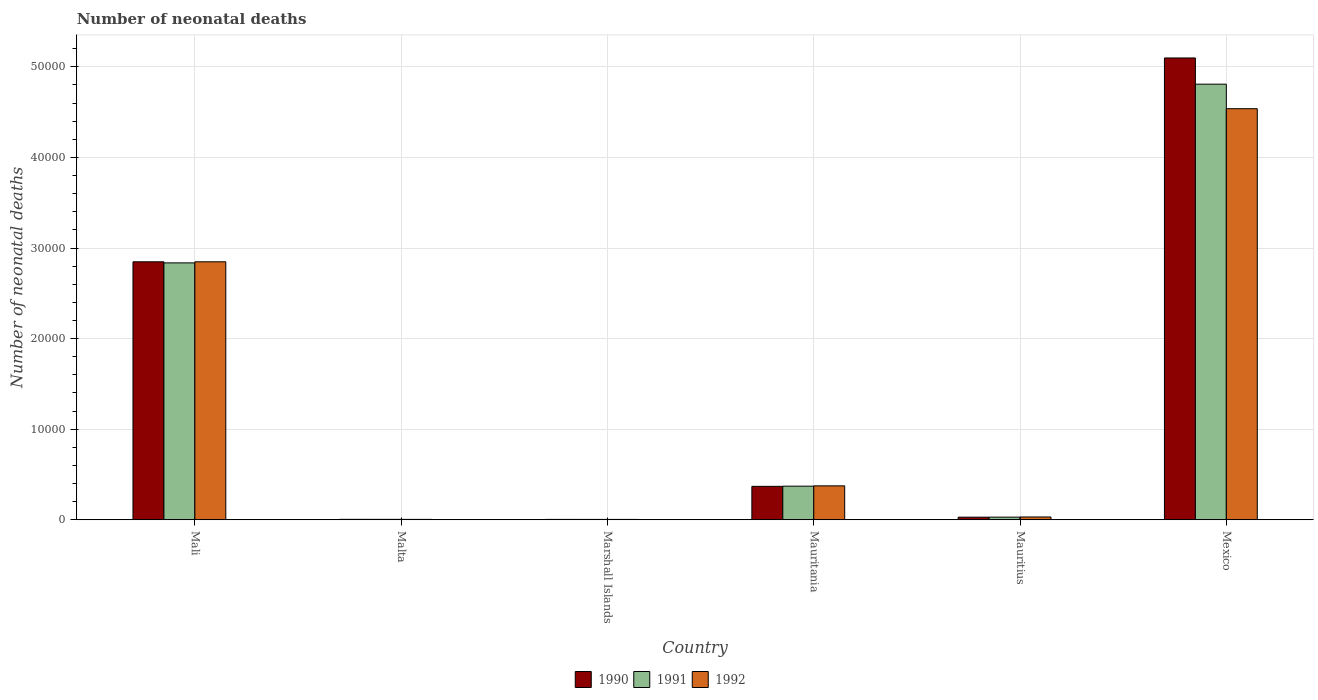How many different coloured bars are there?
Offer a terse response. 3. Are the number of bars on each tick of the X-axis equal?
Keep it short and to the point. Yes. How many bars are there on the 3rd tick from the right?
Offer a very short reply. 3. What is the label of the 1st group of bars from the left?
Make the answer very short. Mali. What is the number of neonatal deaths in in 1992 in Mauritania?
Give a very brief answer. 3743. Across all countries, what is the maximum number of neonatal deaths in in 1991?
Your response must be concise. 4.81e+04. Across all countries, what is the minimum number of neonatal deaths in in 1992?
Your response must be concise. 38. In which country was the number of neonatal deaths in in 1991 minimum?
Your response must be concise. Marshall Islands. What is the total number of neonatal deaths in in 1991 in the graph?
Keep it short and to the point. 8.05e+04. What is the difference between the number of neonatal deaths in in 1991 in Mali and that in Mexico?
Your answer should be very brief. -1.97e+04. What is the difference between the number of neonatal deaths in in 1992 in Mauritania and the number of neonatal deaths in in 1990 in Mexico?
Offer a very short reply. -4.72e+04. What is the average number of neonatal deaths in in 1992 per country?
Your answer should be very brief. 1.30e+04. What is the difference between the number of neonatal deaths in of/in 1992 and number of neonatal deaths in of/in 1991 in Malta?
Provide a short and direct response. -3. What is the ratio of the number of neonatal deaths in in 1991 in Mali to that in Mauritania?
Your answer should be very brief. 7.65. Is the number of neonatal deaths in in 1990 in Mali less than that in Mexico?
Your answer should be compact. Yes. Is the difference between the number of neonatal deaths in in 1992 in Mali and Marshall Islands greater than the difference between the number of neonatal deaths in in 1991 in Mali and Marshall Islands?
Keep it short and to the point. Yes. What is the difference between the highest and the second highest number of neonatal deaths in in 1991?
Make the answer very short. 4.44e+04. What is the difference between the highest and the lowest number of neonatal deaths in in 1992?
Offer a very short reply. 4.53e+04. In how many countries, is the number of neonatal deaths in in 1990 greater than the average number of neonatal deaths in in 1990 taken over all countries?
Keep it short and to the point. 2. What does the 2nd bar from the right in Mauritania represents?
Make the answer very short. 1991. Is it the case that in every country, the sum of the number of neonatal deaths in in 1990 and number of neonatal deaths in in 1992 is greater than the number of neonatal deaths in in 1991?
Your response must be concise. Yes. Are all the bars in the graph horizontal?
Keep it short and to the point. No. Are the values on the major ticks of Y-axis written in scientific E-notation?
Ensure brevity in your answer.  No. Where does the legend appear in the graph?
Make the answer very short. Bottom center. How are the legend labels stacked?
Your response must be concise. Horizontal. What is the title of the graph?
Offer a very short reply. Number of neonatal deaths. Does "1964" appear as one of the legend labels in the graph?
Offer a terse response. No. What is the label or title of the Y-axis?
Provide a succinct answer. Number of neonatal deaths. What is the Number of neonatal deaths in 1990 in Mali?
Keep it short and to the point. 2.85e+04. What is the Number of neonatal deaths in 1991 in Mali?
Your response must be concise. 2.84e+04. What is the Number of neonatal deaths in 1992 in Mali?
Make the answer very short. 2.85e+04. What is the Number of neonatal deaths of 1991 in Marshall Islands?
Keep it short and to the point. 39. What is the Number of neonatal deaths of 1992 in Marshall Islands?
Your answer should be compact. 38. What is the Number of neonatal deaths of 1990 in Mauritania?
Provide a succinct answer. 3690. What is the Number of neonatal deaths in 1991 in Mauritania?
Your response must be concise. 3709. What is the Number of neonatal deaths in 1992 in Mauritania?
Give a very brief answer. 3743. What is the Number of neonatal deaths of 1990 in Mauritius?
Give a very brief answer. 285. What is the Number of neonatal deaths of 1991 in Mauritius?
Offer a very short reply. 289. What is the Number of neonatal deaths in 1992 in Mauritius?
Your response must be concise. 307. What is the Number of neonatal deaths of 1990 in Mexico?
Provide a short and direct response. 5.10e+04. What is the Number of neonatal deaths in 1991 in Mexico?
Provide a short and direct response. 4.81e+04. What is the Number of neonatal deaths in 1992 in Mexico?
Give a very brief answer. 4.54e+04. Across all countries, what is the maximum Number of neonatal deaths in 1990?
Your answer should be very brief. 5.10e+04. Across all countries, what is the maximum Number of neonatal deaths in 1991?
Provide a short and direct response. 4.81e+04. Across all countries, what is the maximum Number of neonatal deaths in 1992?
Offer a very short reply. 4.54e+04. Across all countries, what is the minimum Number of neonatal deaths of 1991?
Your answer should be compact. 39. What is the total Number of neonatal deaths of 1990 in the graph?
Ensure brevity in your answer.  8.35e+04. What is the total Number of neonatal deaths of 1991 in the graph?
Your answer should be compact. 8.05e+04. What is the total Number of neonatal deaths of 1992 in the graph?
Make the answer very short. 7.80e+04. What is the difference between the Number of neonatal deaths of 1990 in Mali and that in Malta?
Your answer should be compact. 2.84e+04. What is the difference between the Number of neonatal deaths of 1991 in Mali and that in Malta?
Keep it short and to the point. 2.83e+04. What is the difference between the Number of neonatal deaths of 1992 in Mali and that in Malta?
Your answer should be very brief. 2.84e+04. What is the difference between the Number of neonatal deaths in 1990 in Mali and that in Marshall Islands?
Offer a very short reply. 2.84e+04. What is the difference between the Number of neonatal deaths of 1991 in Mali and that in Marshall Islands?
Your answer should be very brief. 2.83e+04. What is the difference between the Number of neonatal deaths of 1992 in Mali and that in Marshall Islands?
Your answer should be very brief. 2.84e+04. What is the difference between the Number of neonatal deaths of 1990 in Mali and that in Mauritania?
Ensure brevity in your answer.  2.48e+04. What is the difference between the Number of neonatal deaths in 1991 in Mali and that in Mauritania?
Your answer should be compact. 2.46e+04. What is the difference between the Number of neonatal deaths in 1992 in Mali and that in Mauritania?
Ensure brevity in your answer.  2.47e+04. What is the difference between the Number of neonatal deaths in 1990 in Mali and that in Mauritius?
Offer a very short reply. 2.82e+04. What is the difference between the Number of neonatal deaths in 1991 in Mali and that in Mauritius?
Offer a terse response. 2.81e+04. What is the difference between the Number of neonatal deaths in 1992 in Mali and that in Mauritius?
Provide a succinct answer. 2.82e+04. What is the difference between the Number of neonatal deaths of 1990 in Mali and that in Mexico?
Keep it short and to the point. -2.25e+04. What is the difference between the Number of neonatal deaths of 1991 in Mali and that in Mexico?
Offer a terse response. -1.97e+04. What is the difference between the Number of neonatal deaths of 1992 in Mali and that in Mexico?
Provide a short and direct response. -1.69e+04. What is the difference between the Number of neonatal deaths of 1990 in Malta and that in Mauritania?
Your response must be concise. -3643. What is the difference between the Number of neonatal deaths in 1991 in Malta and that in Mauritania?
Keep it short and to the point. -3664. What is the difference between the Number of neonatal deaths of 1992 in Malta and that in Mauritania?
Keep it short and to the point. -3701. What is the difference between the Number of neonatal deaths of 1990 in Malta and that in Mauritius?
Your answer should be compact. -238. What is the difference between the Number of neonatal deaths in 1991 in Malta and that in Mauritius?
Keep it short and to the point. -244. What is the difference between the Number of neonatal deaths in 1992 in Malta and that in Mauritius?
Your answer should be very brief. -265. What is the difference between the Number of neonatal deaths in 1990 in Malta and that in Mexico?
Your answer should be compact. -5.09e+04. What is the difference between the Number of neonatal deaths in 1991 in Malta and that in Mexico?
Provide a short and direct response. -4.80e+04. What is the difference between the Number of neonatal deaths of 1992 in Malta and that in Mexico?
Offer a very short reply. -4.53e+04. What is the difference between the Number of neonatal deaths in 1990 in Marshall Islands and that in Mauritania?
Make the answer very short. -3650. What is the difference between the Number of neonatal deaths in 1991 in Marshall Islands and that in Mauritania?
Provide a short and direct response. -3670. What is the difference between the Number of neonatal deaths in 1992 in Marshall Islands and that in Mauritania?
Your answer should be very brief. -3705. What is the difference between the Number of neonatal deaths in 1990 in Marshall Islands and that in Mauritius?
Offer a very short reply. -245. What is the difference between the Number of neonatal deaths of 1991 in Marshall Islands and that in Mauritius?
Offer a very short reply. -250. What is the difference between the Number of neonatal deaths of 1992 in Marshall Islands and that in Mauritius?
Your answer should be compact. -269. What is the difference between the Number of neonatal deaths in 1990 in Marshall Islands and that in Mexico?
Your answer should be very brief. -5.09e+04. What is the difference between the Number of neonatal deaths of 1991 in Marshall Islands and that in Mexico?
Offer a very short reply. -4.80e+04. What is the difference between the Number of neonatal deaths in 1992 in Marshall Islands and that in Mexico?
Your answer should be compact. -4.53e+04. What is the difference between the Number of neonatal deaths of 1990 in Mauritania and that in Mauritius?
Provide a succinct answer. 3405. What is the difference between the Number of neonatal deaths of 1991 in Mauritania and that in Mauritius?
Your answer should be very brief. 3420. What is the difference between the Number of neonatal deaths in 1992 in Mauritania and that in Mauritius?
Ensure brevity in your answer.  3436. What is the difference between the Number of neonatal deaths in 1990 in Mauritania and that in Mexico?
Provide a succinct answer. -4.73e+04. What is the difference between the Number of neonatal deaths of 1991 in Mauritania and that in Mexico?
Offer a very short reply. -4.44e+04. What is the difference between the Number of neonatal deaths of 1992 in Mauritania and that in Mexico?
Give a very brief answer. -4.16e+04. What is the difference between the Number of neonatal deaths in 1990 in Mauritius and that in Mexico?
Your response must be concise. -5.07e+04. What is the difference between the Number of neonatal deaths of 1991 in Mauritius and that in Mexico?
Offer a terse response. -4.78e+04. What is the difference between the Number of neonatal deaths of 1992 in Mauritius and that in Mexico?
Give a very brief answer. -4.51e+04. What is the difference between the Number of neonatal deaths in 1990 in Mali and the Number of neonatal deaths in 1991 in Malta?
Give a very brief answer. 2.84e+04. What is the difference between the Number of neonatal deaths of 1990 in Mali and the Number of neonatal deaths of 1992 in Malta?
Give a very brief answer. 2.84e+04. What is the difference between the Number of neonatal deaths in 1991 in Mali and the Number of neonatal deaths in 1992 in Malta?
Your answer should be compact. 2.83e+04. What is the difference between the Number of neonatal deaths in 1990 in Mali and the Number of neonatal deaths in 1991 in Marshall Islands?
Make the answer very short. 2.84e+04. What is the difference between the Number of neonatal deaths of 1990 in Mali and the Number of neonatal deaths of 1992 in Marshall Islands?
Make the answer very short. 2.84e+04. What is the difference between the Number of neonatal deaths of 1991 in Mali and the Number of neonatal deaths of 1992 in Marshall Islands?
Ensure brevity in your answer.  2.83e+04. What is the difference between the Number of neonatal deaths in 1990 in Mali and the Number of neonatal deaths in 1991 in Mauritania?
Provide a succinct answer. 2.48e+04. What is the difference between the Number of neonatal deaths of 1990 in Mali and the Number of neonatal deaths of 1992 in Mauritania?
Your answer should be very brief. 2.47e+04. What is the difference between the Number of neonatal deaths of 1991 in Mali and the Number of neonatal deaths of 1992 in Mauritania?
Keep it short and to the point. 2.46e+04. What is the difference between the Number of neonatal deaths of 1990 in Mali and the Number of neonatal deaths of 1991 in Mauritius?
Provide a short and direct response. 2.82e+04. What is the difference between the Number of neonatal deaths in 1990 in Mali and the Number of neonatal deaths in 1992 in Mauritius?
Keep it short and to the point. 2.82e+04. What is the difference between the Number of neonatal deaths of 1991 in Mali and the Number of neonatal deaths of 1992 in Mauritius?
Your answer should be very brief. 2.81e+04. What is the difference between the Number of neonatal deaths in 1990 in Mali and the Number of neonatal deaths in 1991 in Mexico?
Give a very brief answer. -1.96e+04. What is the difference between the Number of neonatal deaths of 1990 in Mali and the Number of neonatal deaths of 1992 in Mexico?
Your response must be concise. -1.69e+04. What is the difference between the Number of neonatal deaths in 1991 in Mali and the Number of neonatal deaths in 1992 in Mexico?
Ensure brevity in your answer.  -1.70e+04. What is the difference between the Number of neonatal deaths of 1990 in Malta and the Number of neonatal deaths of 1992 in Marshall Islands?
Offer a very short reply. 9. What is the difference between the Number of neonatal deaths in 1991 in Malta and the Number of neonatal deaths in 1992 in Marshall Islands?
Provide a short and direct response. 7. What is the difference between the Number of neonatal deaths in 1990 in Malta and the Number of neonatal deaths in 1991 in Mauritania?
Your answer should be very brief. -3662. What is the difference between the Number of neonatal deaths in 1990 in Malta and the Number of neonatal deaths in 1992 in Mauritania?
Provide a succinct answer. -3696. What is the difference between the Number of neonatal deaths of 1991 in Malta and the Number of neonatal deaths of 1992 in Mauritania?
Your answer should be compact. -3698. What is the difference between the Number of neonatal deaths in 1990 in Malta and the Number of neonatal deaths in 1991 in Mauritius?
Keep it short and to the point. -242. What is the difference between the Number of neonatal deaths of 1990 in Malta and the Number of neonatal deaths of 1992 in Mauritius?
Provide a short and direct response. -260. What is the difference between the Number of neonatal deaths of 1991 in Malta and the Number of neonatal deaths of 1992 in Mauritius?
Keep it short and to the point. -262. What is the difference between the Number of neonatal deaths of 1990 in Malta and the Number of neonatal deaths of 1991 in Mexico?
Your answer should be compact. -4.80e+04. What is the difference between the Number of neonatal deaths in 1990 in Malta and the Number of neonatal deaths in 1992 in Mexico?
Your answer should be compact. -4.53e+04. What is the difference between the Number of neonatal deaths in 1991 in Malta and the Number of neonatal deaths in 1992 in Mexico?
Provide a succinct answer. -4.53e+04. What is the difference between the Number of neonatal deaths in 1990 in Marshall Islands and the Number of neonatal deaths in 1991 in Mauritania?
Keep it short and to the point. -3669. What is the difference between the Number of neonatal deaths of 1990 in Marshall Islands and the Number of neonatal deaths of 1992 in Mauritania?
Ensure brevity in your answer.  -3703. What is the difference between the Number of neonatal deaths in 1991 in Marshall Islands and the Number of neonatal deaths in 1992 in Mauritania?
Make the answer very short. -3704. What is the difference between the Number of neonatal deaths of 1990 in Marshall Islands and the Number of neonatal deaths of 1991 in Mauritius?
Your response must be concise. -249. What is the difference between the Number of neonatal deaths of 1990 in Marshall Islands and the Number of neonatal deaths of 1992 in Mauritius?
Provide a succinct answer. -267. What is the difference between the Number of neonatal deaths in 1991 in Marshall Islands and the Number of neonatal deaths in 1992 in Mauritius?
Provide a succinct answer. -268. What is the difference between the Number of neonatal deaths in 1990 in Marshall Islands and the Number of neonatal deaths in 1991 in Mexico?
Offer a terse response. -4.80e+04. What is the difference between the Number of neonatal deaths in 1990 in Marshall Islands and the Number of neonatal deaths in 1992 in Mexico?
Ensure brevity in your answer.  -4.53e+04. What is the difference between the Number of neonatal deaths of 1991 in Marshall Islands and the Number of neonatal deaths of 1992 in Mexico?
Make the answer very short. -4.53e+04. What is the difference between the Number of neonatal deaths in 1990 in Mauritania and the Number of neonatal deaths in 1991 in Mauritius?
Provide a succinct answer. 3401. What is the difference between the Number of neonatal deaths in 1990 in Mauritania and the Number of neonatal deaths in 1992 in Mauritius?
Ensure brevity in your answer.  3383. What is the difference between the Number of neonatal deaths in 1991 in Mauritania and the Number of neonatal deaths in 1992 in Mauritius?
Keep it short and to the point. 3402. What is the difference between the Number of neonatal deaths in 1990 in Mauritania and the Number of neonatal deaths in 1991 in Mexico?
Your answer should be compact. -4.44e+04. What is the difference between the Number of neonatal deaths in 1990 in Mauritania and the Number of neonatal deaths in 1992 in Mexico?
Provide a succinct answer. -4.17e+04. What is the difference between the Number of neonatal deaths in 1991 in Mauritania and the Number of neonatal deaths in 1992 in Mexico?
Ensure brevity in your answer.  -4.17e+04. What is the difference between the Number of neonatal deaths of 1990 in Mauritius and the Number of neonatal deaths of 1991 in Mexico?
Provide a succinct answer. -4.78e+04. What is the difference between the Number of neonatal deaths in 1990 in Mauritius and the Number of neonatal deaths in 1992 in Mexico?
Your answer should be very brief. -4.51e+04. What is the difference between the Number of neonatal deaths in 1991 in Mauritius and the Number of neonatal deaths in 1992 in Mexico?
Your response must be concise. -4.51e+04. What is the average Number of neonatal deaths in 1990 per country?
Give a very brief answer. 1.39e+04. What is the average Number of neonatal deaths of 1991 per country?
Your response must be concise. 1.34e+04. What is the average Number of neonatal deaths in 1992 per country?
Your answer should be very brief. 1.30e+04. What is the difference between the Number of neonatal deaths of 1990 and Number of neonatal deaths of 1991 in Mali?
Your answer should be compact. 120. What is the difference between the Number of neonatal deaths in 1990 and Number of neonatal deaths in 1992 in Mali?
Offer a terse response. 0. What is the difference between the Number of neonatal deaths in 1991 and Number of neonatal deaths in 1992 in Mali?
Give a very brief answer. -120. What is the difference between the Number of neonatal deaths of 1990 and Number of neonatal deaths of 1991 in Malta?
Make the answer very short. 2. What is the difference between the Number of neonatal deaths of 1990 and Number of neonatal deaths of 1991 in Mauritania?
Keep it short and to the point. -19. What is the difference between the Number of neonatal deaths of 1990 and Number of neonatal deaths of 1992 in Mauritania?
Provide a succinct answer. -53. What is the difference between the Number of neonatal deaths in 1991 and Number of neonatal deaths in 1992 in Mauritania?
Ensure brevity in your answer.  -34. What is the difference between the Number of neonatal deaths of 1990 and Number of neonatal deaths of 1992 in Mauritius?
Provide a short and direct response. -22. What is the difference between the Number of neonatal deaths of 1990 and Number of neonatal deaths of 1991 in Mexico?
Your response must be concise. 2892. What is the difference between the Number of neonatal deaths of 1990 and Number of neonatal deaths of 1992 in Mexico?
Make the answer very short. 5601. What is the difference between the Number of neonatal deaths in 1991 and Number of neonatal deaths in 1992 in Mexico?
Offer a terse response. 2709. What is the ratio of the Number of neonatal deaths of 1990 in Mali to that in Malta?
Keep it short and to the point. 605.91. What is the ratio of the Number of neonatal deaths in 1991 in Mali to that in Malta?
Offer a terse response. 630.18. What is the ratio of the Number of neonatal deaths of 1992 in Mali to that in Malta?
Make the answer very short. 678.05. What is the ratio of the Number of neonatal deaths of 1990 in Mali to that in Marshall Islands?
Provide a succinct answer. 711.95. What is the ratio of the Number of neonatal deaths in 1991 in Mali to that in Marshall Islands?
Provide a succinct answer. 727.13. What is the ratio of the Number of neonatal deaths of 1992 in Mali to that in Marshall Islands?
Offer a terse response. 749.42. What is the ratio of the Number of neonatal deaths in 1990 in Mali to that in Mauritania?
Give a very brief answer. 7.72. What is the ratio of the Number of neonatal deaths in 1991 in Mali to that in Mauritania?
Provide a succinct answer. 7.65. What is the ratio of the Number of neonatal deaths in 1992 in Mali to that in Mauritania?
Keep it short and to the point. 7.61. What is the ratio of the Number of neonatal deaths of 1990 in Mali to that in Mauritius?
Give a very brief answer. 99.92. What is the ratio of the Number of neonatal deaths in 1991 in Mali to that in Mauritius?
Your answer should be compact. 98.12. What is the ratio of the Number of neonatal deaths in 1992 in Mali to that in Mauritius?
Provide a succinct answer. 92.76. What is the ratio of the Number of neonatal deaths in 1990 in Mali to that in Mexico?
Offer a very short reply. 0.56. What is the ratio of the Number of neonatal deaths of 1991 in Mali to that in Mexico?
Provide a short and direct response. 0.59. What is the ratio of the Number of neonatal deaths in 1992 in Mali to that in Mexico?
Ensure brevity in your answer.  0.63. What is the ratio of the Number of neonatal deaths of 1990 in Malta to that in Marshall Islands?
Offer a terse response. 1.18. What is the ratio of the Number of neonatal deaths in 1991 in Malta to that in Marshall Islands?
Give a very brief answer. 1.15. What is the ratio of the Number of neonatal deaths in 1992 in Malta to that in Marshall Islands?
Your answer should be very brief. 1.11. What is the ratio of the Number of neonatal deaths of 1990 in Malta to that in Mauritania?
Give a very brief answer. 0.01. What is the ratio of the Number of neonatal deaths in 1991 in Malta to that in Mauritania?
Provide a succinct answer. 0.01. What is the ratio of the Number of neonatal deaths in 1992 in Malta to that in Mauritania?
Your answer should be compact. 0.01. What is the ratio of the Number of neonatal deaths of 1990 in Malta to that in Mauritius?
Your answer should be compact. 0.16. What is the ratio of the Number of neonatal deaths of 1991 in Malta to that in Mauritius?
Ensure brevity in your answer.  0.16. What is the ratio of the Number of neonatal deaths of 1992 in Malta to that in Mauritius?
Provide a succinct answer. 0.14. What is the ratio of the Number of neonatal deaths in 1990 in Malta to that in Mexico?
Keep it short and to the point. 0. What is the ratio of the Number of neonatal deaths of 1991 in Malta to that in Mexico?
Provide a succinct answer. 0. What is the ratio of the Number of neonatal deaths of 1992 in Malta to that in Mexico?
Provide a succinct answer. 0. What is the ratio of the Number of neonatal deaths of 1990 in Marshall Islands to that in Mauritania?
Give a very brief answer. 0.01. What is the ratio of the Number of neonatal deaths of 1991 in Marshall Islands to that in Mauritania?
Ensure brevity in your answer.  0.01. What is the ratio of the Number of neonatal deaths in 1992 in Marshall Islands to that in Mauritania?
Your answer should be compact. 0.01. What is the ratio of the Number of neonatal deaths in 1990 in Marshall Islands to that in Mauritius?
Your answer should be very brief. 0.14. What is the ratio of the Number of neonatal deaths in 1991 in Marshall Islands to that in Mauritius?
Offer a very short reply. 0.13. What is the ratio of the Number of neonatal deaths in 1992 in Marshall Islands to that in Mauritius?
Your answer should be compact. 0.12. What is the ratio of the Number of neonatal deaths of 1990 in Marshall Islands to that in Mexico?
Ensure brevity in your answer.  0. What is the ratio of the Number of neonatal deaths in 1991 in Marshall Islands to that in Mexico?
Your answer should be very brief. 0. What is the ratio of the Number of neonatal deaths in 1992 in Marshall Islands to that in Mexico?
Your answer should be very brief. 0. What is the ratio of the Number of neonatal deaths in 1990 in Mauritania to that in Mauritius?
Offer a terse response. 12.95. What is the ratio of the Number of neonatal deaths of 1991 in Mauritania to that in Mauritius?
Give a very brief answer. 12.83. What is the ratio of the Number of neonatal deaths in 1992 in Mauritania to that in Mauritius?
Your response must be concise. 12.19. What is the ratio of the Number of neonatal deaths of 1990 in Mauritania to that in Mexico?
Provide a succinct answer. 0.07. What is the ratio of the Number of neonatal deaths of 1991 in Mauritania to that in Mexico?
Give a very brief answer. 0.08. What is the ratio of the Number of neonatal deaths of 1992 in Mauritania to that in Mexico?
Your answer should be compact. 0.08. What is the ratio of the Number of neonatal deaths of 1990 in Mauritius to that in Mexico?
Your response must be concise. 0.01. What is the ratio of the Number of neonatal deaths of 1991 in Mauritius to that in Mexico?
Your response must be concise. 0.01. What is the ratio of the Number of neonatal deaths of 1992 in Mauritius to that in Mexico?
Provide a short and direct response. 0.01. What is the difference between the highest and the second highest Number of neonatal deaths of 1990?
Keep it short and to the point. 2.25e+04. What is the difference between the highest and the second highest Number of neonatal deaths in 1991?
Provide a succinct answer. 1.97e+04. What is the difference between the highest and the second highest Number of neonatal deaths in 1992?
Keep it short and to the point. 1.69e+04. What is the difference between the highest and the lowest Number of neonatal deaths of 1990?
Provide a succinct answer. 5.09e+04. What is the difference between the highest and the lowest Number of neonatal deaths of 1991?
Your response must be concise. 4.80e+04. What is the difference between the highest and the lowest Number of neonatal deaths in 1992?
Your answer should be compact. 4.53e+04. 